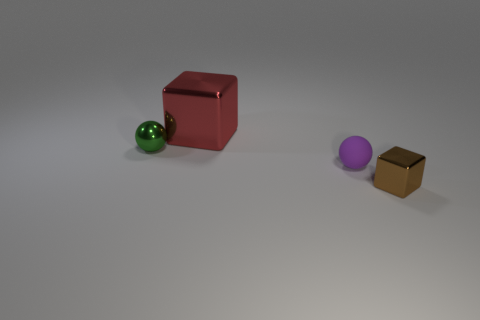There is a tiny ball right of the tiny metallic object behind the tiny brown shiny thing; what number of things are in front of it?
Your response must be concise. 1. There is a block on the right side of the rubber thing; what color is it?
Your answer should be compact. Brown. There is a shiny object left of the block left of the small brown thing; what is its shape?
Provide a short and direct response. Sphere. Does the small cube have the same color as the metal ball?
Provide a succinct answer. No. What number of spheres are either brown objects or small green objects?
Ensure brevity in your answer.  1. There is a tiny object that is both left of the tiny brown object and in front of the green metal thing; what material is it?
Provide a short and direct response. Rubber. There is a red block; how many tiny purple rubber balls are in front of it?
Make the answer very short. 1. Are the sphere in front of the tiny green metallic object and the cube behind the small brown shiny cube made of the same material?
Ensure brevity in your answer.  No. How many objects are either spheres that are on the right side of the red shiny cube or big green balls?
Provide a succinct answer. 1. Are there fewer small green balls in front of the green shiny thing than tiny brown shiny cubes behind the big red shiny cube?
Provide a short and direct response. No. 